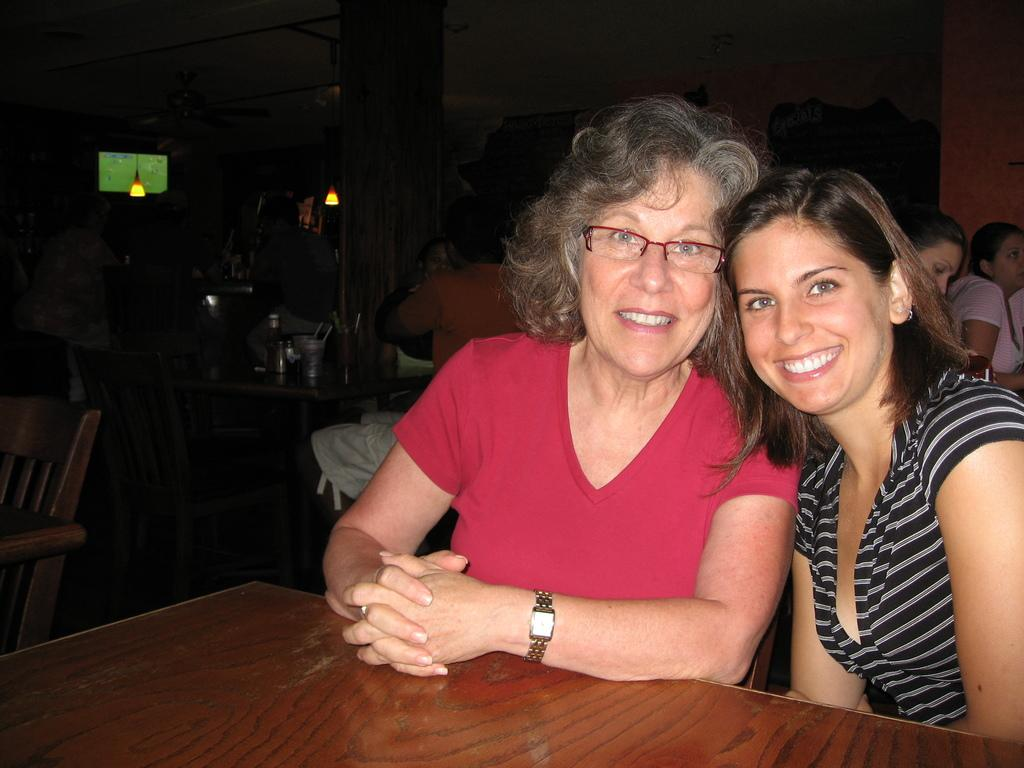How many women are in the image? There are two women in the image. What are the women doing in the image? The women are sitting in chairs and smiling. What can be seen in the background of the image? There is a lamp, a chair, a table, and a group of persons sitting in the background of the image. What type of butter is being used to trick the stove in the image? There is no stove, butter, or trickery present in the image. 